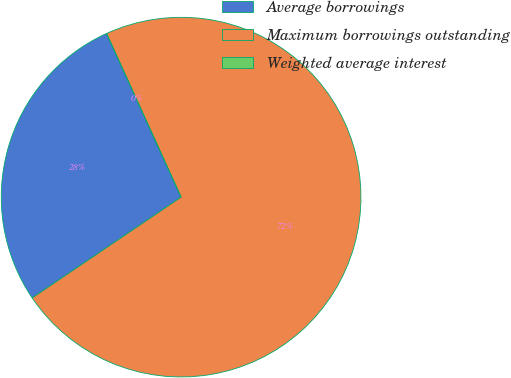<chart> <loc_0><loc_0><loc_500><loc_500><pie_chart><fcel>Average borrowings<fcel>Maximum borrowings outstanding<fcel>Weighted average interest<nl><fcel>27.67%<fcel>72.33%<fcel>0.0%<nl></chart> 